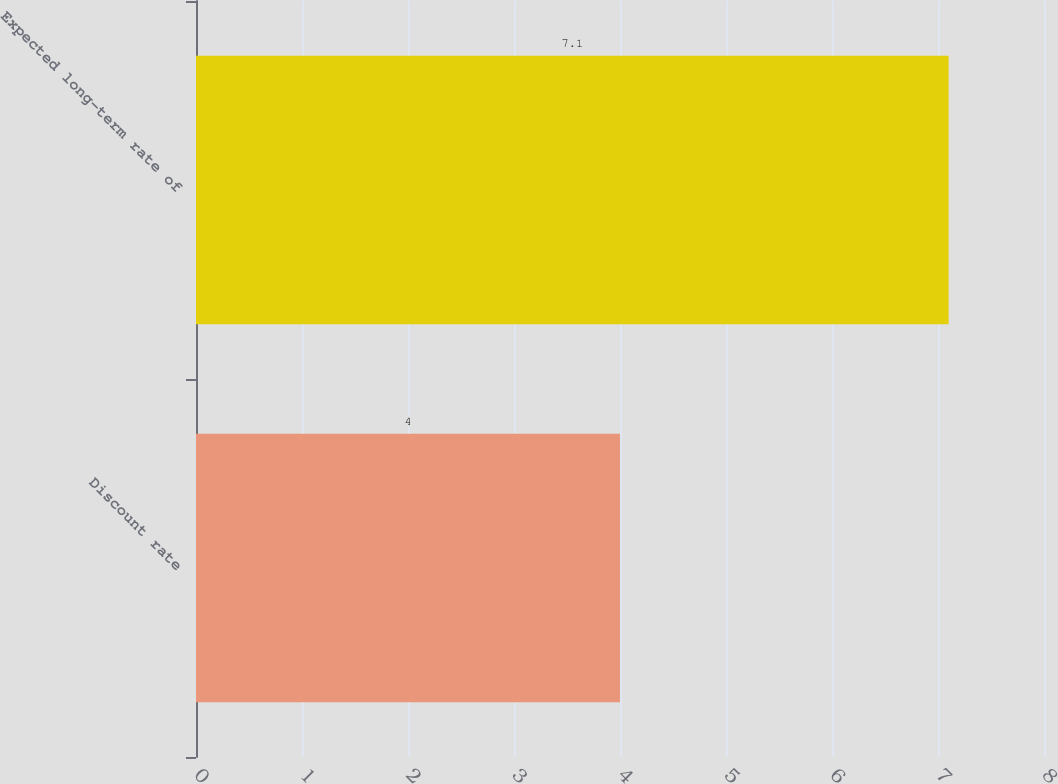Convert chart to OTSL. <chart><loc_0><loc_0><loc_500><loc_500><bar_chart><fcel>Discount rate<fcel>Expected long-term rate of<nl><fcel>4<fcel>7.1<nl></chart> 